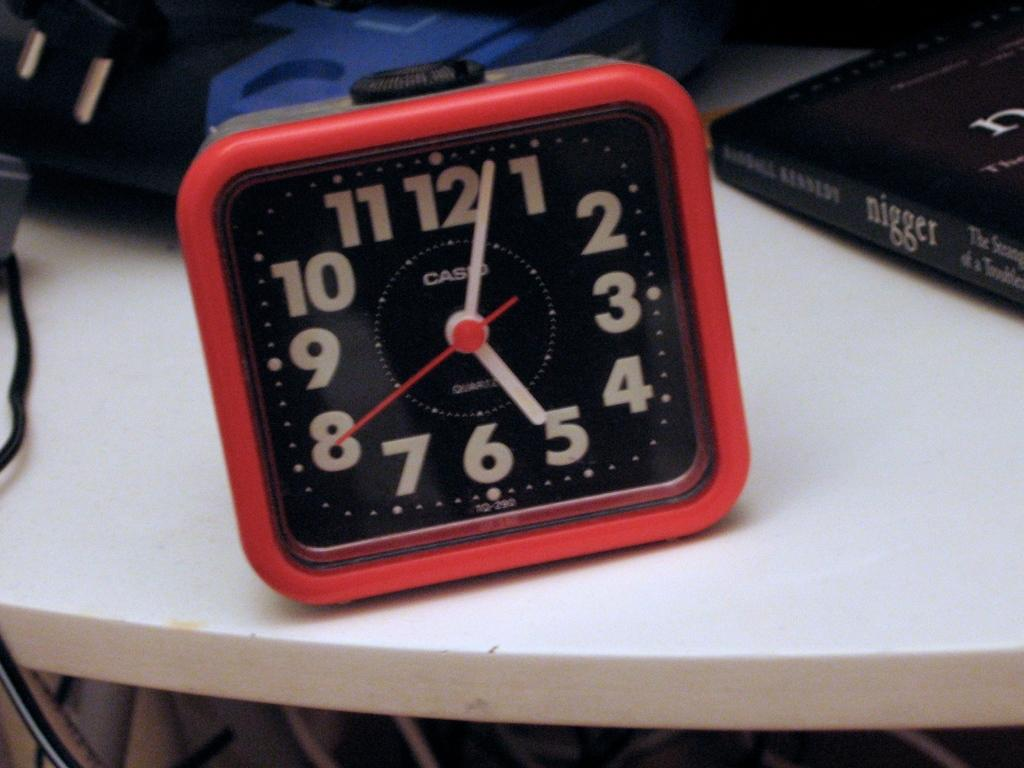<image>
Create a compact narrative representing the image presented. A red and black Casio clock on a white table. 